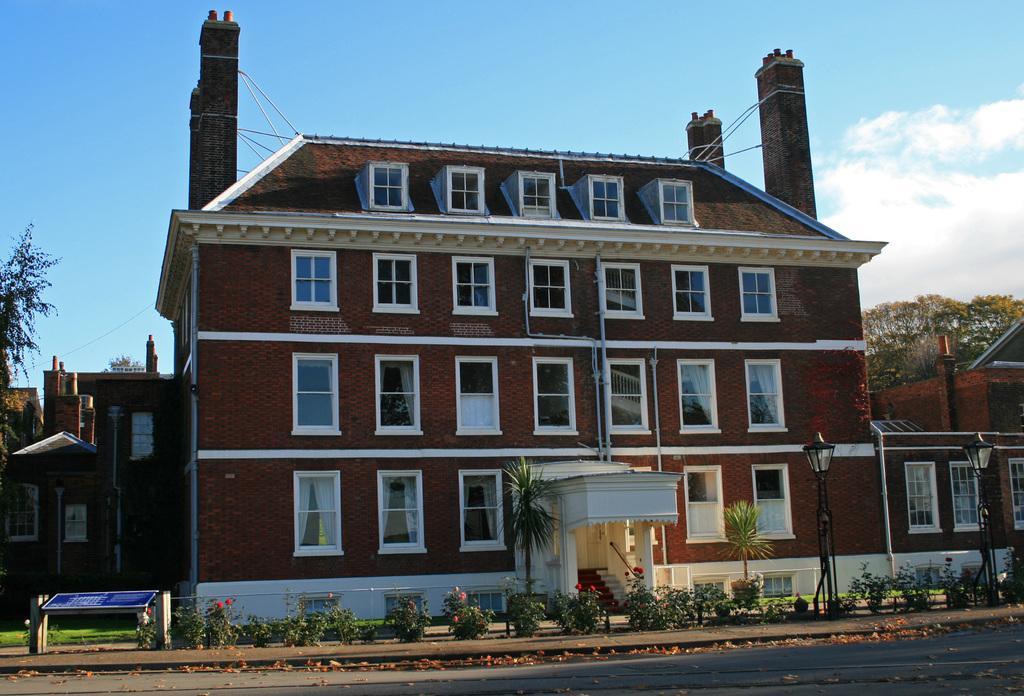Could you give a brief overview of what you see in this image? There are plants, trees and poles present at the bottom of this image. We can see trees and a building in the background. The cloudy sky is at the top of this image. 